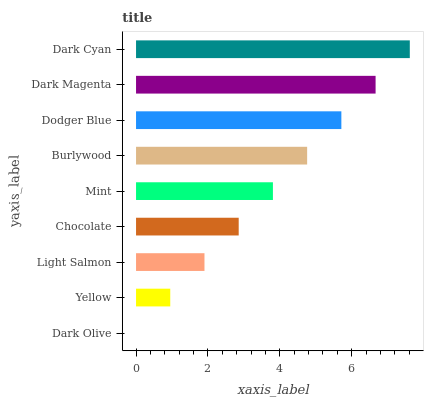Is Dark Olive the minimum?
Answer yes or no. Yes. Is Dark Cyan the maximum?
Answer yes or no. Yes. Is Yellow the minimum?
Answer yes or no. No. Is Yellow the maximum?
Answer yes or no. No. Is Yellow greater than Dark Olive?
Answer yes or no. Yes. Is Dark Olive less than Yellow?
Answer yes or no. Yes. Is Dark Olive greater than Yellow?
Answer yes or no. No. Is Yellow less than Dark Olive?
Answer yes or no. No. Is Mint the high median?
Answer yes or no. Yes. Is Mint the low median?
Answer yes or no. Yes. Is Yellow the high median?
Answer yes or no. No. Is Dark Olive the low median?
Answer yes or no. No. 